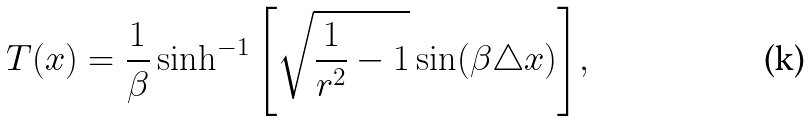Convert formula to latex. <formula><loc_0><loc_0><loc_500><loc_500>T ( x ) = \frac { 1 } { \beta } \sinh ^ { - 1 } { \left [ \sqrt { \frac { 1 } { r ^ { 2 } } - 1 } \sin ( \beta \triangle x ) \right ] } ,</formula> 